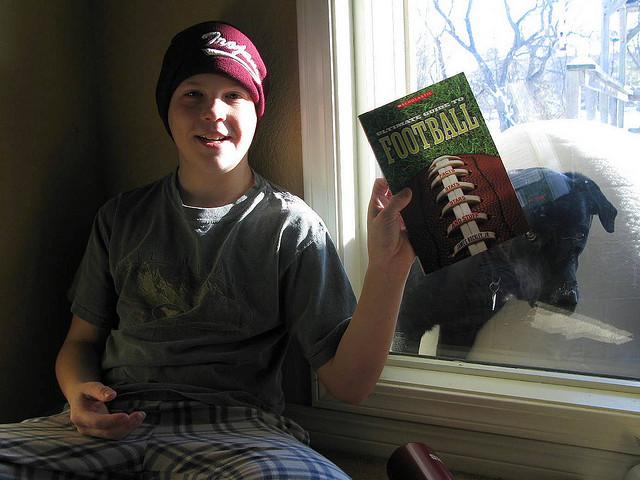What does the boy have on his head?
Concise answer only. Hat. What is on the child's shirt?
Concise answer only. Green. What is the boy holding?
Give a very brief answer. Book. What is outside the window?
Write a very short answer. Dog. 